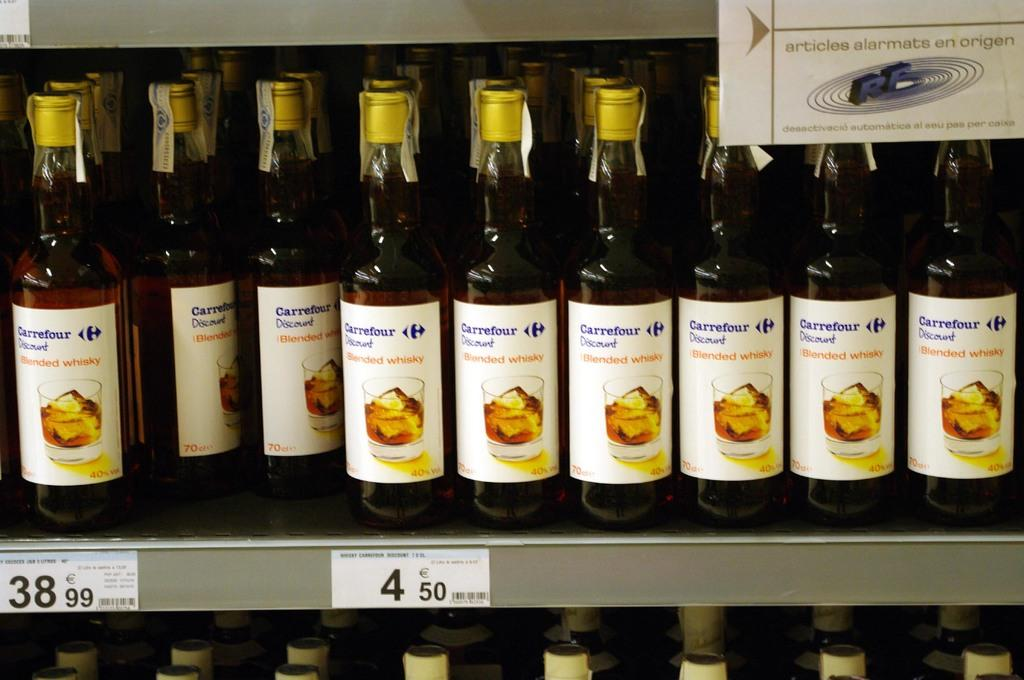Provide a one-sentence caption for the provided image. A display of Carrefour Blended Whiskey sits on the shelf. 